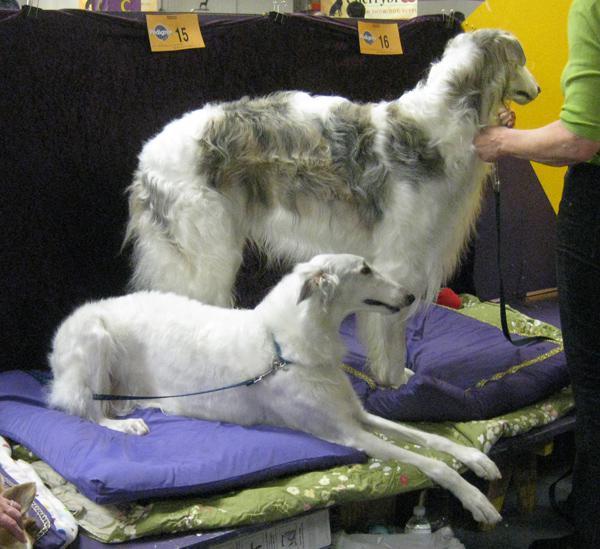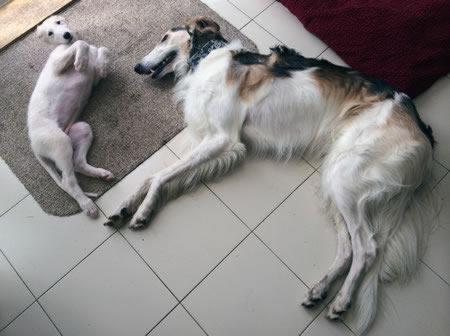The first image is the image on the left, the second image is the image on the right. For the images shown, is this caption "There is 1 dog facing left in both images." true? Answer yes or no. No. The first image is the image on the left, the second image is the image on the right. Considering the images on both sides, is "There is a woman in a denim shirt touching a dog in one of the images." valid? Answer yes or no. No. 